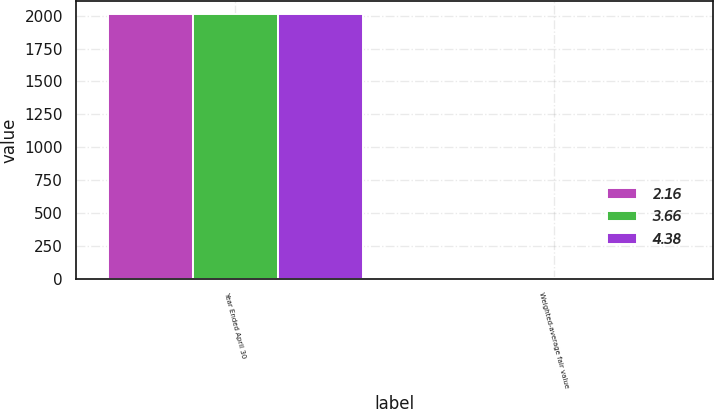Convert chart. <chart><loc_0><loc_0><loc_500><loc_500><stacked_bar_chart><ecel><fcel>Year Ended April 30<fcel>Weighted-average fair value<nl><fcel>2.16<fcel>2011<fcel>2.25<nl><fcel>3.66<fcel>2010<fcel>3.27<nl><fcel>4.38<fcel>2009<fcel>3.8<nl></chart> 